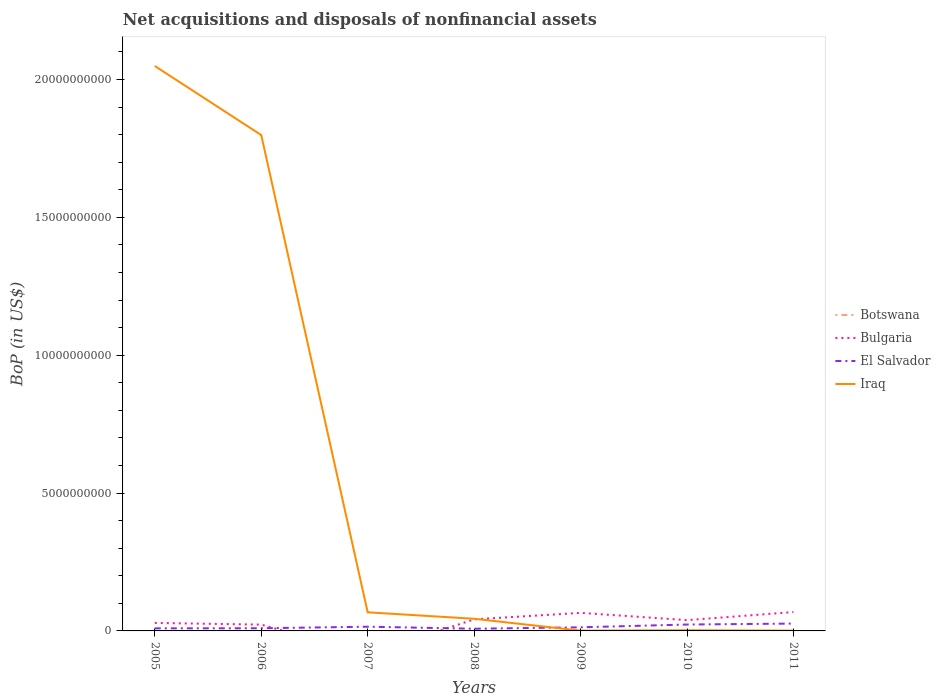How many different coloured lines are there?
Provide a succinct answer. 4. Does the line corresponding to El Salvador intersect with the line corresponding to Bulgaria?
Give a very brief answer. Yes. Is the number of lines equal to the number of legend labels?
Your answer should be compact. No. What is the total Balance of Payments in El Salvador in the graph?
Keep it short and to the point. -1.38e+08. What is the difference between the highest and the second highest Balance of Payments in Iraq?
Offer a very short reply. 2.05e+1. Is the Balance of Payments in Botswana strictly greater than the Balance of Payments in El Salvador over the years?
Your answer should be compact. Yes. Are the values on the major ticks of Y-axis written in scientific E-notation?
Provide a short and direct response. No. Does the graph contain grids?
Your answer should be very brief. No. Where does the legend appear in the graph?
Your response must be concise. Center right. How many legend labels are there?
Offer a terse response. 4. What is the title of the graph?
Offer a terse response. Net acquisitions and disposals of nonfinancial assets. What is the label or title of the Y-axis?
Make the answer very short. BoP (in US$). What is the BoP (in US$) of Botswana in 2005?
Ensure brevity in your answer.  0. What is the BoP (in US$) of Bulgaria in 2005?
Give a very brief answer. 2.90e+08. What is the BoP (in US$) of El Salvador in 2005?
Your answer should be very brief. 9.36e+07. What is the BoP (in US$) in Iraq in 2005?
Offer a very short reply. 2.05e+1. What is the BoP (in US$) in Bulgaria in 2006?
Ensure brevity in your answer.  2.28e+08. What is the BoP (in US$) of El Salvador in 2006?
Make the answer very short. 9.68e+07. What is the BoP (in US$) in Iraq in 2006?
Offer a very short reply. 1.80e+1. What is the BoP (in US$) of Bulgaria in 2007?
Provide a short and direct response. 0. What is the BoP (in US$) of El Salvador in 2007?
Keep it short and to the point. 1.53e+08. What is the BoP (in US$) of Iraq in 2007?
Your answer should be compact. 6.75e+08. What is the BoP (in US$) in Bulgaria in 2008?
Give a very brief answer. 4.20e+08. What is the BoP (in US$) in El Salvador in 2008?
Offer a terse response. 7.98e+07. What is the BoP (in US$) of Iraq in 2008?
Keep it short and to the point. 4.41e+08. What is the BoP (in US$) in Botswana in 2009?
Offer a very short reply. 0. What is the BoP (in US$) in Bulgaria in 2009?
Your response must be concise. 6.55e+08. What is the BoP (in US$) of El Salvador in 2009?
Your answer should be compact. 1.31e+08. What is the BoP (in US$) of Iraq in 2009?
Provide a short and direct response. 1.02e+07. What is the BoP (in US$) of Bulgaria in 2010?
Keep it short and to the point. 3.91e+08. What is the BoP (in US$) of El Salvador in 2010?
Make the answer very short. 2.32e+08. What is the BoP (in US$) of Iraq in 2010?
Offer a terse response. 2.53e+07. What is the BoP (in US$) in Botswana in 2011?
Keep it short and to the point. 3.77e+05. What is the BoP (in US$) of Bulgaria in 2011?
Provide a succinct answer. 6.84e+08. What is the BoP (in US$) of El Salvador in 2011?
Provide a short and direct response. 2.66e+08. What is the BoP (in US$) of Iraq in 2011?
Provide a succinct answer. 1.10e+07. Across all years, what is the maximum BoP (in US$) of Botswana?
Your answer should be very brief. 3.77e+05. Across all years, what is the maximum BoP (in US$) in Bulgaria?
Keep it short and to the point. 6.84e+08. Across all years, what is the maximum BoP (in US$) in El Salvador?
Offer a terse response. 2.66e+08. Across all years, what is the maximum BoP (in US$) in Iraq?
Offer a terse response. 2.05e+1. Across all years, what is the minimum BoP (in US$) in Botswana?
Your answer should be very brief. 0. Across all years, what is the minimum BoP (in US$) of Bulgaria?
Provide a succinct answer. 0. Across all years, what is the minimum BoP (in US$) in El Salvador?
Your answer should be very brief. 7.98e+07. Across all years, what is the minimum BoP (in US$) in Iraq?
Your response must be concise. 1.02e+07. What is the total BoP (in US$) in Botswana in the graph?
Your response must be concise. 3.77e+05. What is the total BoP (in US$) of Bulgaria in the graph?
Provide a succinct answer. 2.67e+09. What is the total BoP (in US$) of El Salvador in the graph?
Your answer should be very brief. 1.05e+09. What is the total BoP (in US$) of Iraq in the graph?
Offer a very short reply. 3.96e+1. What is the difference between the BoP (in US$) in Bulgaria in 2005 and that in 2006?
Your response must be concise. 6.12e+07. What is the difference between the BoP (in US$) in El Salvador in 2005 and that in 2006?
Ensure brevity in your answer.  -3.20e+06. What is the difference between the BoP (in US$) of Iraq in 2005 and that in 2006?
Your response must be concise. 2.50e+09. What is the difference between the BoP (in US$) of El Salvador in 2005 and that in 2007?
Offer a terse response. -5.92e+07. What is the difference between the BoP (in US$) in Iraq in 2005 and that in 2007?
Your answer should be compact. 1.98e+1. What is the difference between the BoP (in US$) in Bulgaria in 2005 and that in 2008?
Make the answer very short. -1.30e+08. What is the difference between the BoP (in US$) in El Salvador in 2005 and that in 2008?
Offer a terse response. 1.38e+07. What is the difference between the BoP (in US$) of Iraq in 2005 and that in 2008?
Keep it short and to the point. 2.00e+1. What is the difference between the BoP (in US$) of Bulgaria in 2005 and that in 2009?
Offer a very short reply. -3.65e+08. What is the difference between the BoP (in US$) in El Salvador in 2005 and that in 2009?
Offer a terse response. -3.76e+07. What is the difference between the BoP (in US$) of Iraq in 2005 and that in 2009?
Your answer should be compact. 2.05e+1. What is the difference between the BoP (in US$) of Bulgaria in 2005 and that in 2010?
Provide a succinct answer. -1.02e+08. What is the difference between the BoP (in US$) of El Salvador in 2005 and that in 2010?
Ensure brevity in your answer.  -1.38e+08. What is the difference between the BoP (in US$) of Iraq in 2005 and that in 2010?
Your response must be concise. 2.05e+1. What is the difference between the BoP (in US$) in Bulgaria in 2005 and that in 2011?
Your answer should be compact. -3.94e+08. What is the difference between the BoP (in US$) in El Salvador in 2005 and that in 2011?
Ensure brevity in your answer.  -1.73e+08. What is the difference between the BoP (in US$) in Iraq in 2005 and that in 2011?
Your response must be concise. 2.05e+1. What is the difference between the BoP (in US$) in El Salvador in 2006 and that in 2007?
Keep it short and to the point. -5.60e+07. What is the difference between the BoP (in US$) in Iraq in 2006 and that in 2007?
Give a very brief answer. 1.73e+1. What is the difference between the BoP (in US$) of Bulgaria in 2006 and that in 2008?
Your answer should be very brief. -1.91e+08. What is the difference between the BoP (in US$) in El Salvador in 2006 and that in 2008?
Give a very brief answer. 1.70e+07. What is the difference between the BoP (in US$) of Iraq in 2006 and that in 2008?
Offer a terse response. 1.75e+1. What is the difference between the BoP (in US$) in Bulgaria in 2006 and that in 2009?
Your answer should be very brief. -4.26e+08. What is the difference between the BoP (in US$) of El Salvador in 2006 and that in 2009?
Provide a succinct answer. -3.44e+07. What is the difference between the BoP (in US$) in Iraq in 2006 and that in 2009?
Offer a terse response. 1.80e+1. What is the difference between the BoP (in US$) of Bulgaria in 2006 and that in 2010?
Provide a succinct answer. -1.63e+08. What is the difference between the BoP (in US$) of El Salvador in 2006 and that in 2010?
Your response must be concise. -1.35e+08. What is the difference between the BoP (in US$) of Iraq in 2006 and that in 2010?
Provide a succinct answer. 1.80e+1. What is the difference between the BoP (in US$) in Bulgaria in 2006 and that in 2011?
Keep it short and to the point. -4.55e+08. What is the difference between the BoP (in US$) of El Salvador in 2006 and that in 2011?
Provide a short and direct response. -1.70e+08. What is the difference between the BoP (in US$) of Iraq in 2006 and that in 2011?
Provide a succinct answer. 1.80e+1. What is the difference between the BoP (in US$) in El Salvador in 2007 and that in 2008?
Provide a succinct answer. 7.30e+07. What is the difference between the BoP (in US$) of Iraq in 2007 and that in 2008?
Your answer should be compact. 2.34e+08. What is the difference between the BoP (in US$) in El Salvador in 2007 and that in 2009?
Make the answer very short. 2.16e+07. What is the difference between the BoP (in US$) in Iraq in 2007 and that in 2009?
Give a very brief answer. 6.65e+08. What is the difference between the BoP (in US$) of El Salvador in 2007 and that in 2010?
Your answer should be very brief. -7.92e+07. What is the difference between the BoP (in US$) of Iraq in 2007 and that in 2010?
Keep it short and to the point. 6.50e+08. What is the difference between the BoP (in US$) in El Salvador in 2007 and that in 2011?
Keep it short and to the point. -1.14e+08. What is the difference between the BoP (in US$) of Iraq in 2007 and that in 2011?
Your answer should be very brief. 6.64e+08. What is the difference between the BoP (in US$) of Bulgaria in 2008 and that in 2009?
Offer a terse response. -2.35e+08. What is the difference between the BoP (in US$) of El Salvador in 2008 and that in 2009?
Offer a very short reply. -5.14e+07. What is the difference between the BoP (in US$) of Iraq in 2008 and that in 2009?
Give a very brief answer. 4.31e+08. What is the difference between the BoP (in US$) of Bulgaria in 2008 and that in 2010?
Your answer should be very brief. 2.82e+07. What is the difference between the BoP (in US$) of El Salvador in 2008 and that in 2010?
Offer a very short reply. -1.52e+08. What is the difference between the BoP (in US$) of Iraq in 2008 and that in 2010?
Your response must be concise. 4.16e+08. What is the difference between the BoP (in US$) in Bulgaria in 2008 and that in 2011?
Keep it short and to the point. -2.64e+08. What is the difference between the BoP (in US$) in El Salvador in 2008 and that in 2011?
Provide a short and direct response. -1.87e+08. What is the difference between the BoP (in US$) in Iraq in 2008 and that in 2011?
Your response must be concise. 4.30e+08. What is the difference between the BoP (in US$) in Bulgaria in 2009 and that in 2010?
Offer a terse response. 2.63e+08. What is the difference between the BoP (in US$) in El Salvador in 2009 and that in 2010?
Provide a short and direct response. -1.01e+08. What is the difference between the BoP (in US$) of Iraq in 2009 and that in 2010?
Keep it short and to the point. -1.51e+07. What is the difference between the BoP (in US$) of Bulgaria in 2009 and that in 2011?
Provide a succinct answer. -2.90e+07. What is the difference between the BoP (in US$) of El Salvador in 2009 and that in 2011?
Your answer should be very brief. -1.35e+08. What is the difference between the BoP (in US$) in Iraq in 2009 and that in 2011?
Your response must be concise. -8.00e+05. What is the difference between the BoP (in US$) of Bulgaria in 2010 and that in 2011?
Provide a short and direct response. -2.92e+08. What is the difference between the BoP (in US$) in El Salvador in 2010 and that in 2011?
Keep it short and to the point. -3.44e+07. What is the difference between the BoP (in US$) of Iraq in 2010 and that in 2011?
Offer a very short reply. 1.43e+07. What is the difference between the BoP (in US$) in Bulgaria in 2005 and the BoP (in US$) in El Salvador in 2006?
Provide a short and direct response. 1.93e+08. What is the difference between the BoP (in US$) of Bulgaria in 2005 and the BoP (in US$) of Iraq in 2006?
Make the answer very short. -1.77e+1. What is the difference between the BoP (in US$) of El Salvador in 2005 and the BoP (in US$) of Iraq in 2006?
Your response must be concise. -1.79e+1. What is the difference between the BoP (in US$) of Bulgaria in 2005 and the BoP (in US$) of El Salvador in 2007?
Your answer should be very brief. 1.37e+08. What is the difference between the BoP (in US$) in Bulgaria in 2005 and the BoP (in US$) in Iraq in 2007?
Offer a very short reply. -3.85e+08. What is the difference between the BoP (in US$) of El Salvador in 2005 and the BoP (in US$) of Iraq in 2007?
Ensure brevity in your answer.  -5.82e+08. What is the difference between the BoP (in US$) of Bulgaria in 2005 and the BoP (in US$) of El Salvador in 2008?
Keep it short and to the point. 2.10e+08. What is the difference between the BoP (in US$) of Bulgaria in 2005 and the BoP (in US$) of Iraq in 2008?
Provide a short and direct response. -1.51e+08. What is the difference between the BoP (in US$) in El Salvador in 2005 and the BoP (in US$) in Iraq in 2008?
Keep it short and to the point. -3.47e+08. What is the difference between the BoP (in US$) of Bulgaria in 2005 and the BoP (in US$) of El Salvador in 2009?
Your answer should be compact. 1.58e+08. What is the difference between the BoP (in US$) of Bulgaria in 2005 and the BoP (in US$) of Iraq in 2009?
Offer a terse response. 2.79e+08. What is the difference between the BoP (in US$) of El Salvador in 2005 and the BoP (in US$) of Iraq in 2009?
Your response must be concise. 8.34e+07. What is the difference between the BoP (in US$) in Bulgaria in 2005 and the BoP (in US$) in El Salvador in 2010?
Offer a very short reply. 5.77e+07. What is the difference between the BoP (in US$) of Bulgaria in 2005 and the BoP (in US$) of Iraq in 2010?
Give a very brief answer. 2.64e+08. What is the difference between the BoP (in US$) of El Salvador in 2005 and the BoP (in US$) of Iraq in 2010?
Your answer should be very brief. 6.83e+07. What is the difference between the BoP (in US$) in Bulgaria in 2005 and the BoP (in US$) in El Salvador in 2011?
Your answer should be compact. 2.33e+07. What is the difference between the BoP (in US$) of Bulgaria in 2005 and the BoP (in US$) of Iraq in 2011?
Provide a succinct answer. 2.79e+08. What is the difference between the BoP (in US$) in El Salvador in 2005 and the BoP (in US$) in Iraq in 2011?
Offer a very short reply. 8.26e+07. What is the difference between the BoP (in US$) in Bulgaria in 2006 and the BoP (in US$) in El Salvador in 2007?
Your answer should be compact. 7.57e+07. What is the difference between the BoP (in US$) in Bulgaria in 2006 and the BoP (in US$) in Iraq in 2007?
Your answer should be compact. -4.47e+08. What is the difference between the BoP (in US$) of El Salvador in 2006 and the BoP (in US$) of Iraq in 2007?
Your answer should be compact. -5.78e+08. What is the difference between the BoP (in US$) of Bulgaria in 2006 and the BoP (in US$) of El Salvador in 2008?
Provide a succinct answer. 1.49e+08. What is the difference between the BoP (in US$) in Bulgaria in 2006 and the BoP (in US$) in Iraq in 2008?
Offer a terse response. -2.12e+08. What is the difference between the BoP (in US$) of El Salvador in 2006 and the BoP (in US$) of Iraq in 2008?
Provide a short and direct response. -3.44e+08. What is the difference between the BoP (in US$) of Bulgaria in 2006 and the BoP (in US$) of El Salvador in 2009?
Ensure brevity in your answer.  9.73e+07. What is the difference between the BoP (in US$) of Bulgaria in 2006 and the BoP (in US$) of Iraq in 2009?
Offer a very short reply. 2.18e+08. What is the difference between the BoP (in US$) in El Salvador in 2006 and the BoP (in US$) in Iraq in 2009?
Your response must be concise. 8.66e+07. What is the difference between the BoP (in US$) in Bulgaria in 2006 and the BoP (in US$) in El Salvador in 2010?
Give a very brief answer. -3.52e+06. What is the difference between the BoP (in US$) of Bulgaria in 2006 and the BoP (in US$) of Iraq in 2010?
Make the answer very short. 2.03e+08. What is the difference between the BoP (in US$) of El Salvador in 2006 and the BoP (in US$) of Iraq in 2010?
Provide a succinct answer. 7.15e+07. What is the difference between the BoP (in US$) of Bulgaria in 2006 and the BoP (in US$) of El Salvador in 2011?
Offer a terse response. -3.79e+07. What is the difference between the BoP (in US$) of Bulgaria in 2006 and the BoP (in US$) of Iraq in 2011?
Your response must be concise. 2.17e+08. What is the difference between the BoP (in US$) of El Salvador in 2006 and the BoP (in US$) of Iraq in 2011?
Ensure brevity in your answer.  8.58e+07. What is the difference between the BoP (in US$) in El Salvador in 2007 and the BoP (in US$) in Iraq in 2008?
Provide a succinct answer. -2.88e+08. What is the difference between the BoP (in US$) in El Salvador in 2007 and the BoP (in US$) in Iraq in 2009?
Offer a terse response. 1.43e+08. What is the difference between the BoP (in US$) in El Salvador in 2007 and the BoP (in US$) in Iraq in 2010?
Give a very brief answer. 1.28e+08. What is the difference between the BoP (in US$) of El Salvador in 2007 and the BoP (in US$) of Iraq in 2011?
Ensure brevity in your answer.  1.42e+08. What is the difference between the BoP (in US$) of Bulgaria in 2008 and the BoP (in US$) of El Salvador in 2009?
Give a very brief answer. 2.88e+08. What is the difference between the BoP (in US$) in Bulgaria in 2008 and the BoP (in US$) in Iraq in 2009?
Offer a terse response. 4.09e+08. What is the difference between the BoP (in US$) of El Salvador in 2008 and the BoP (in US$) of Iraq in 2009?
Provide a short and direct response. 6.96e+07. What is the difference between the BoP (in US$) in Bulgaria in 2008 and the BoP (in US$) in El Salvador in 2010?
Keep it short and to the point. 1.88e+08. What is the difference between the BoP (in US$) of Bulgaria in 2008 and the BoP (in US$) of Iraq in 2010?
Keep it short and to the point. 3.94e+08. What is the difference between the BoP (in US$) of El Salvador in 2008 and the BoP (in US$) of Iraq in 2010?
Give a very brief answer. 5.45e+07. What is the difference between the BoP (in US$) of Bulgaria in 2008 and the BoP (in US$) of El Salvador in 2011?
Provide a succinct answer. 1.53e+08. What is the difference between the BoP (in US$) in Bulgaria in 2008 and the BoP (in US$) in Iraq in 2011?
Your answer should be very brief. 4.09e+08. What is the difference between the BoP (in US$) in El Salvador in 2008 and the BoP (in US$) in Iraq in 2011?
Your response must be concise. 6.88e+07. What is the difference between the BoP (in US$) of Bulgaria in 2009 and the BoP (in US$) of El Salvador in 2010?
Make the answer very short. 4.23e+08. What is the difference between the BoP (in US$) in Bulgaria in 2009 and the BoP (in US$) in Iraq in 2010?
Provide a short and direct response. 6.29e+08. What is the difference between the BoP (in US$) in El Salvador in 2009 and the BoP (in US$) in Iraq in 2010?
Offer a terse response. 1.06e+08. What is the difference between the BoP (in US$) in Bulgaria in 2009 and the BoP (in US$) in El Salvador in 2011?
Provide a succinct answer. 3.88e+08. What is the difference between the BoP (in US$) of Bulgaria in 2009 and the BoP (in US$) of Iraq in 2011?
Provide a short and direct response. 6.44e+08. What is the difference between the BoP (in US$) of El Salvador in 2009 and the BoP (in US$) of Iraq in 2011?
Provide a succinct answer. 1.20e+08. What is the difference between the BoP (in US$) of Bulgaria in 2010 and the BoP (in US$) of El Salvador in 2011?
Give a very brief answer. 1.25e+08. What is the difference between the BoP (in US$) of Bulgaria in 2010 and the BoP (in US$) of Iraq in 2011?
Make the answer very short. 3.80e+08. What is the difference between the BoP (in US$) of El Salvador in 2010 and the BoP (in US$) of Iraq in 2011?
Keep it short and to the point. 2.21e+08. What is the average BoP (in US$) in Botswana per year?
Ensure brevity in your answer.  5.39e+04. What is the average BoP (in US$) of Bulgaria per year?
Your answer should be very brief. 3.81e+08. What is the average BoP (in US$) in El Salvador per year?
Your answer should be very brief. 1.50e+08. What is the average BoP (in US$) of Iraq per year?
Offer a very short reply. 5.66e+09. In the year 2005, what is the difference between the BoP (in US$) of Bulgaria and BoP (in US$) of El Salvador?
Offer a terse response. 1.96e+08. In the year 2005, what is the difference between the BoP (in US$) of Bulgaria and BoP (in US$) of Iraq?
Offer a terse response. -2.02e+1. In the year 2005, what is the difference between the BoP (in US$) in El Salvador and BoP (in US$) in Iraq?
Your answer should be compact. -2.04e+1. In the year 2006, what is the difference between the BoP (in US$) in Bulgaria and BoP (in US$) in El Salvador?
Offer a terse response. 1.32e+08. In the year 2006, what is the difference between the BoP (in US$) in Bulgaria and BoP (in US$) in Iraq?
Offer a terse response. -1.78e+1. In the year 2006, what is the difference between the BoP (in US$) of El Salvador and BoP (in US$) of Iraq?
Give a very brief answer. -1.79e+1. In the year 2007, what is the difference between the BoP (in US$) in El Salvador and BoP (in US$) in Iraq?
Ensure brevity in your answer.  -5.22e+08. In the year 2008, what is the difference between the BoP (in US$) in Bulgaria and BoP (in US$) in El Salvador?
Ensure brevity in your answer.  3.40e+08. In the year 2008, what is the difference between the BoP (in US$) in Bulgaria and BoP (in US$) in Iraq?
Your response must be concise. -2.12e+07. In the year 2008, what is the difference between the BoP (in US$) of El Salvador and BoP (in US$) of Iraq?
Provide a succinct answer. -3.61e+08. In the year 2009, what is the difference between the BoP (in US$) in Bulgaria and BoP (in US$) in El Salvador?
Your answer should be very brief. 5.24e+08. In the year 2009, what is the difference between the BoP (in US$) of Bulgaria and BoP (in US$) of Iraq?
Offer a terse response. 6.45e+08. In the year 2009, what is the difference between the BoP (in US$) in El Salvador and BoP (in US$) in Iraq?
Offer a terse response. 1.21e+08. In the year 2010, what is the difference between the BoP (in US$) in Bulgaria and BoP (in US$) in El Salvador?
Your response must be concise. 1.59e+08. In the year 2010, what is the difference between the BoP (in US$) in Bulgaria and BoP (in US$) in Iraq?
Make the answer very short. 3.66e+08. In the year 2010, what is the difference between the BoP (in US$) in El Salvador and BoP (in US$) in Iraq?
Your answer should be compact. 2.07e+08. In the year 2011, what is the difference between the BoP (in US$) of Botswana and BoP (in US$) of Bulgaria?
Your response must be concise. -6.83e+08. In the year 2011, what is the difference between the BoP (in US$) in Botswana and BoP (in US$) in El Salvador?
Your answer should be compact. -2.66e+08. In the year 2011, what is the difference between the BoP (in US$) in Botswana and BoP (in US$) in Iraq?
Your answer should be very brief. -1.06e+07. In the year 2011, what is the difference between the BoP (in US$) of Bulgaria and BoP (in US$) of El Salvador?
Your answer should be compact. 4.17e+08. In the year 2011, what is the difference between the BoP (in US$) in Bulgaria and BoP (in US$) in Iraq?
Provide a short and direct response. 6.73e+08. In the year 2011, what is the difference between the BoP (in US$) in El Salvador and BoP (in US$) in Iraq?
Offer a very short reply. 2.55e+08. What is the ratio of the BoP (in US$) in Bulgaria in 2005 to that in 2006?
Your answer should be compact. 1.27. What is the ratio of the BoP (in US$) of El Salvador in 2005 to that in 2006?
Offer a very short reply. 0.97. What is the ratio of the BoP (in US$) in Iraq in 2005 to that in 2006?
Offer a very short reply. 1.14. What is the ratio of the BoP (in US$) of El Salvador in 2005 to that in 2007?
Your response must be concise. 0.61. What is the ratio of the BoP (in US$) of Iraq in 2005 to that in 2007?
Your answer should be very brief. 30.35. What is the ratio of the BoP (in US$) in Bulgaria in 2005 to that in 2008?
Ensure brevity in your answer.  0.69. What is the ratio of the BoP (in US$) of El Salvador in 2005 to that in 2008?
Give a very brief answer. 1.17. What is the ratio of the BoP (in US$) in Iraq in 2005 to that in 2008?
Provide a succinct answer. 46.48. What is the ratio of the BoP (in US$) in Bulgaria in 2005 to that in 2009?
Ensure brevity in your answer.  0.44. What is the ratio of the BoP (in US$) of El Salvador in 2005 to that in 2009?
Provide a short and direct response. 0.71. What is the ratio of the BoP (in US$) in Iraq in 2005 to that in 2009?
Your answer should be compact. 2008.72. What is the ratio of the BoP (in US$) in Bulgaria in 2005 to that in 2010?
Ensure brevity in your answer.  0.74. What is the ratio of the BoP (in US$) in El Salvador in 2005 to that in 2010?
Your answer should be compact. 0.4. What is the ratio of the BoP (in US$) in Iraq in 2005 to that in 2010?
Give a very brief answer. 809.84. What is the ratio of the BoP (in US$) in Bulgaria in 2005 to that in 2011?
Give a very brief answer. 0.42. What is the ratio of the BoP (in US$) in El Salvador in 2005 to that in 2011?
Offer a terse response. 0.35. What is the ratio of the BoP (in US$) in Iraq in 2005 to that in 2011?
Make the answer very short. 1862.63. What is the ratio of the BoP (in US$) in El Salvador in 2006 to that in 2007?
Provide a short and direct response. 0.63. What is the ratio of the BoP (in US$) of Iraq in 2006 to that in 2007?
Ensure brevity in your answer.  26.64. What is the ratio of the BoP (in US$) of Bulgaria in 2006 to that in 2008?
Give a very brief answer. 0.54. What is the ratio of the BoP (in US$) in El Salvador in 2006 to that in 2008?
Your answer should be compact. 1.21. What is the ratio of the BoP (in US$) of Iraq in 2006 to that in 2008?
Offer a terse response. 40.8. What is the ratio of the BoP (in US$) of Bulgaria in 2006 to that in 2009?
Keep it short and to the point. 0.35. What is the ratio of the BoP (in US$) in El Salvador in 2006 to that in 2009?
Keep it short and to the point. 0.74. What is the ratio of the BoP (in US$) in Iraq in 2006 to that in 2009?
Your answer should be very brief. 1763.14. What is the ratio of the BoP (in US$) in Bulgaria in 2006 to that in 2010?
Provide a succinct answer. 0.58. What is the ratio of the BoP (in US$) of El Salvador in 2006 to that in 2010?
Your response must be concise. 0.42. What is the ratio of the BoP (in US$) of Iraq in 2006 to that in 2010?
Offer a terse response. 710.83. What is the ratio of the BoP (in US$) of Bulgaria in 2006 to that in 2011?
Provide a short and direct response. 0.33. What is the ratio of the BoP (in US$) of El Salvador in 2006 to that in 2011?
Provide a succinct answer. 0.36. What is the ratio of the BoP (in US$) of Iraq in 2006 to that in 2011?
Offer a terse response. 1634.91. What is the ratio of the BoP (in US$) in El Salvador in 2007 to that in 2008?
Make the answer very short. 1.91. What is the ratio of the BoP (in US$) in Iraq in 2007 to that in 2008?
Your answer should be compact. 1.53. What is the ratio of the BoP (in US$) in El Salvador in 2007 to that in 2009?
Your answer should be very brief. 1.16. What is the ratio of the BoP (in US$) of Iraq in 2007 to that in 2009?
Offer a very short reply. 66.19. What is the ratio of the BoP (in US$) in El Salvador in 2007 to that in 2010?
Provide a short and direct response. 0.66. What is the ratio of the BoP (in US$) in Iraq in 2007 to that in 2010?
Make the answer very short. 26.68. What is the ratio of the BoP (in US$) in El Salvador in 2007 to that in 2011?
Your answer should be compact. 0.57. What is the ratio of the BoP (in US$) in Iraq in 2007 to that in 2011?
Your answer should be very brief. 61.37. What is the ratio of the BoP (in US$) in Bulgaria in 2008 to that in 2009?
Your answer should be compact. 0.64. What is the ratio of the BoP (in US$) of El Salvador in 2008 to that in 2009?
Ensure brevity in your answer.  0.61. What is the ratio of the BoP (in US$) of Iraq in 2008 to that in 2009?
Make the answer very short. 43.22. What is the ratio of the BoP (in US$) of Bulgaria in 2008 to that in 2010?
Offer a very short reply. 1.07. What is the ratio of the BoP (in US$) of El Salvador in 2008 to that in 2010?
Give a very brief answer. 0.34. What is the ratio of the BoP (in US$) of Iraq in 2008 to that in 2010?
Offer a very short reply. 17.42. What is the ratio of the BoP (in US$) in Bulgaria in 2008 to that in 2011?
Provide a succinct answer. 0.61. What is the ratio of the BoP (in US$) in El Salvador in 2008 to that in 2011?
Your answer should be very brief. 0.3. What is the ratio of the BoP (in US$) of Iraq in 2008 to that in 2011?
Your answer should be very brief. 40.07. What is the ratio of the BoP (in US$) of Bulgaria in 2009 to that in 2010?
Give a very brief answer. 1.67. What is the ratio of the BoP (in US$) in El Salvador in 2009 to that in 2010?
Your response must be concise. 0.57. What is the ratio of the BoP (in US$) in Iraq in 2009 to that in 2010?
Keep it short and to the point. 0.4. What is the ratio of the BoP (in US$) of Bulgaria in 2009 to that in 2011?
Keep it short and to the point. 0.96. What is the ratio of the BoP (in US$) of El Salvador in 2009 to that in 2011?
Offer a very short reply. 0.49. What is the ratio of the BoP (in US$) in Iraq in 2009 to that in 2011?
Provide a succinct answer. 0.93. What is the ratio of the BoP (in US$) in Bulgaria in 2010 to that in 2011?
Make the answer very short. 0.57. What is the ratio of the BoP (in US$) in El Salvador in 2010 to that in 2011?
Your response must be concise. 0.87. What is the ratio of the BoP (in US$) in Iraq in 2010 to that in 2011?
Give a very brief answer. 2.3. What is the difference between the highest and the second highest BoP (in US$) of Bulgaria?
Offer a very short reply. 2.90e+07. What is the difference between the highest and the second highest BoP (in US$) in El Salvador?
Make the answer very short. 3.44e+07. What is the difference between the highest and the second highest BoP (in US$) in Iraq?
Provide a succinct answer. 2.50e+09. What is the difference between the highest and the lowest BoP (in US$) in Botswana?
Provide a short and direct response. 3.77e+05. What is the difference between the highest and the lowest BoP (in US$) of Bulgaria?
Offer a very short reply. 6.84e+08. What is the difference between the highest and the lowest BoP (in US$) in El Salvador?
Give a very brief answer. 1.87e+08. What is the difference between the highest and the lowest BoP (in US$) of Iraq?
Make the answer very short. 2.05e+1. 